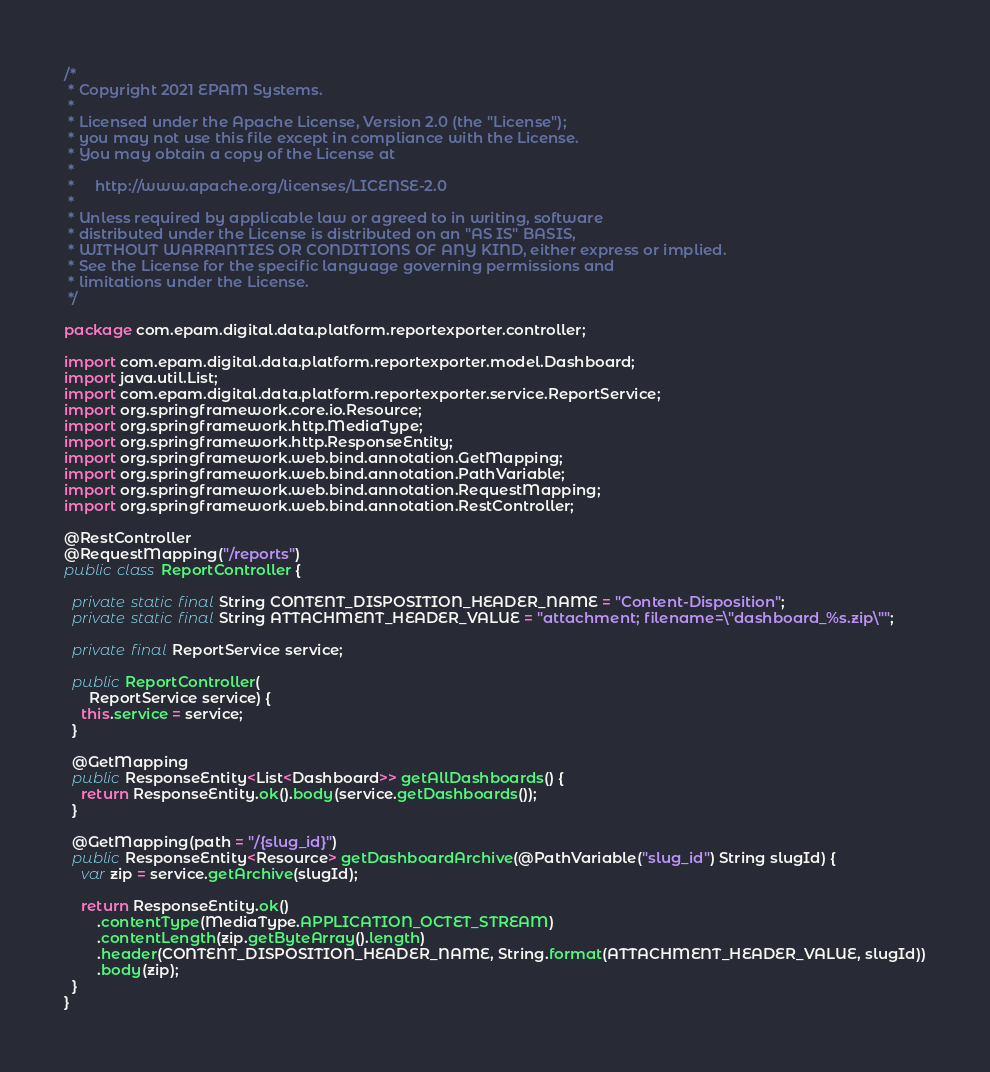<code> <loc_0><loc_0><loc_500><loc_500><_Java_>/*
 * Copyright 2021 EPAM Systems.
 *
 * Licensed under the Apache License, Version 2.0 (the "License");
 * you may not use this file except in compliance with the License.
 * You may obtain a copy of the License at
 *
 *     http://www.apache.org/licenses/LICENSE-2.0
 *
 * Unless required by applicable law or agreed to in writing, software
 * distributed under the License is distributed on an "AS IS" BASIS,
 * WITHOUT WARRANTIES OR CONDITIONS OF ANY KIND, either express or implied.
 * See the License for the specific language governing permissions and
 * limitations under the License.
 */

package com.epam.digital.data.platform.reportexporter.controller;

import com.epam.digital.data.platform.reportexporter.model.Dashboard;
import java.util.List;
import com.epam.digital.data.platform.reportexporter.service.ReportService;
import org.springframework.core.io.Resource;
import org.springframework.http.MediaType;
import org.springframework.http.ResponseEntity;
import org.springframework.web.bind.annotation.GetMapping;
import org.springframework.web.bind.annotation.PathVariable;
import org.springframework.web.bind.annotation.RequestMapping;
import org.springframework.web.bind.annotation.RestController;

@RestController
@RequestMapping("/reports")
public class ReportController {

  private static final String CONTENT_DISPOSITION_HEADER_NAME = "Content-Disposition";
  private static final String ATTACHMENT_HEADER_VALUE = "attachment; filename=\"dashboard_%s.zip\"";

  private final ReportService service;

  public ReportController(
      ReportService service) {
    this.service = service;
  }

  @GetMapping
  public ResponseEntity<List<Dashboard>> getAllDashboards() {
    return ResponseEntity.ok().body(service.getDashboards());
  }

  @GetMapping(path = "/{slug_id}")
  public ResponseEntity<Resource> getDashboardArchive(@PathVariable("slug_id") String slugId) {
    var zip = service.getArchive(slugId);

    return ResponseEntity.ok()
        .contentType(MediaType.APPLICATION_OCTET_STREAM)
        .contentLength(zip.getByteArray().length)
        .header(CONTENT_DISPOSITION_HEADER_NAME, String.format(ATTACHMENT_HEADER_VALUE, slugId))
        .body(zip);
  }
}
</code> 